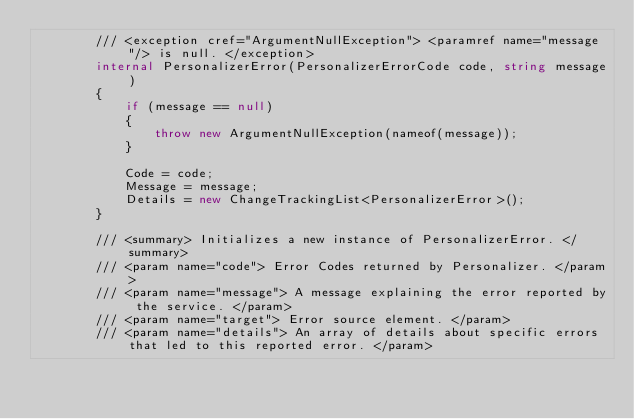Convert code to text. <code><loc_0><loc_0><loc_500><loc_500><_C#_>        /// <exception cref="ArgumentNullException"> <paramref name="message"/> is null. </exception>
        internal PersonalizerError(PersonalizerErrorCode code, string message)
        {
            if (message == null)
            {
                throw new ArgumentNullException(nameof(message));
            }

            Code = code;
            Message = message;
            Details = new ChangeTrackingList<PersonalizerError>();
        }

        /// <summary> Initializes a new instance of PersonalizerError. </summary>
        /// <param name="code"> Error Codes returned by Personalizer. </param>
        /// <param name="message"> A message explaining the error reported by the service. </param>
        /// <param name="target"> Error source element. </param>
        /// <param name="details"> An array of details about specific errors that led to this reported error. </param></code> 